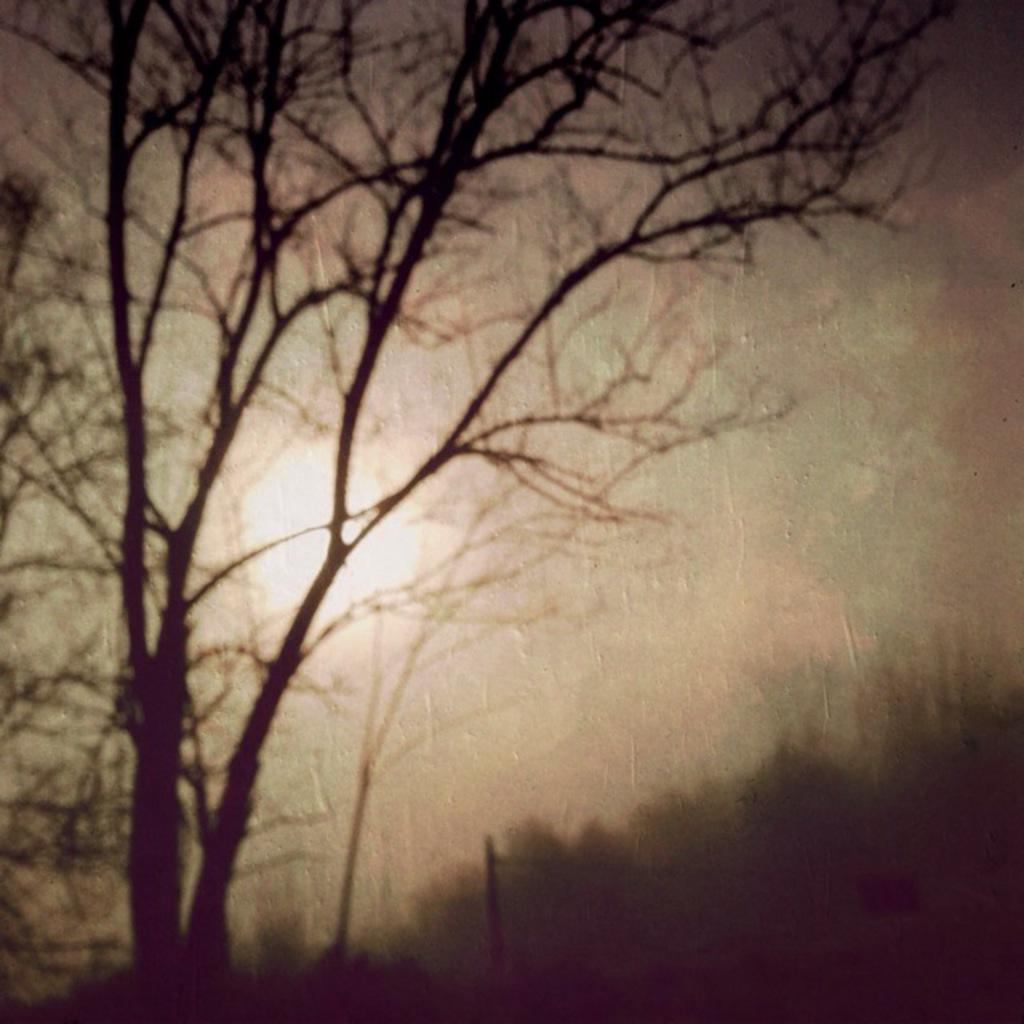What is depicted in the image? There is a picture of a tree in the image. What celestial body can be seen in the image? The sun is visible in the image. What else is visible in the image besides the tree and sun? The sky is visible in the image. What type of haircut does the tree have in the image? The tree does not have a haircut, as it is a non-living object and cannot have a haircut. 